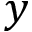<formula> <loc_0><loc_0><loc_500><loc_500>y</formula> 